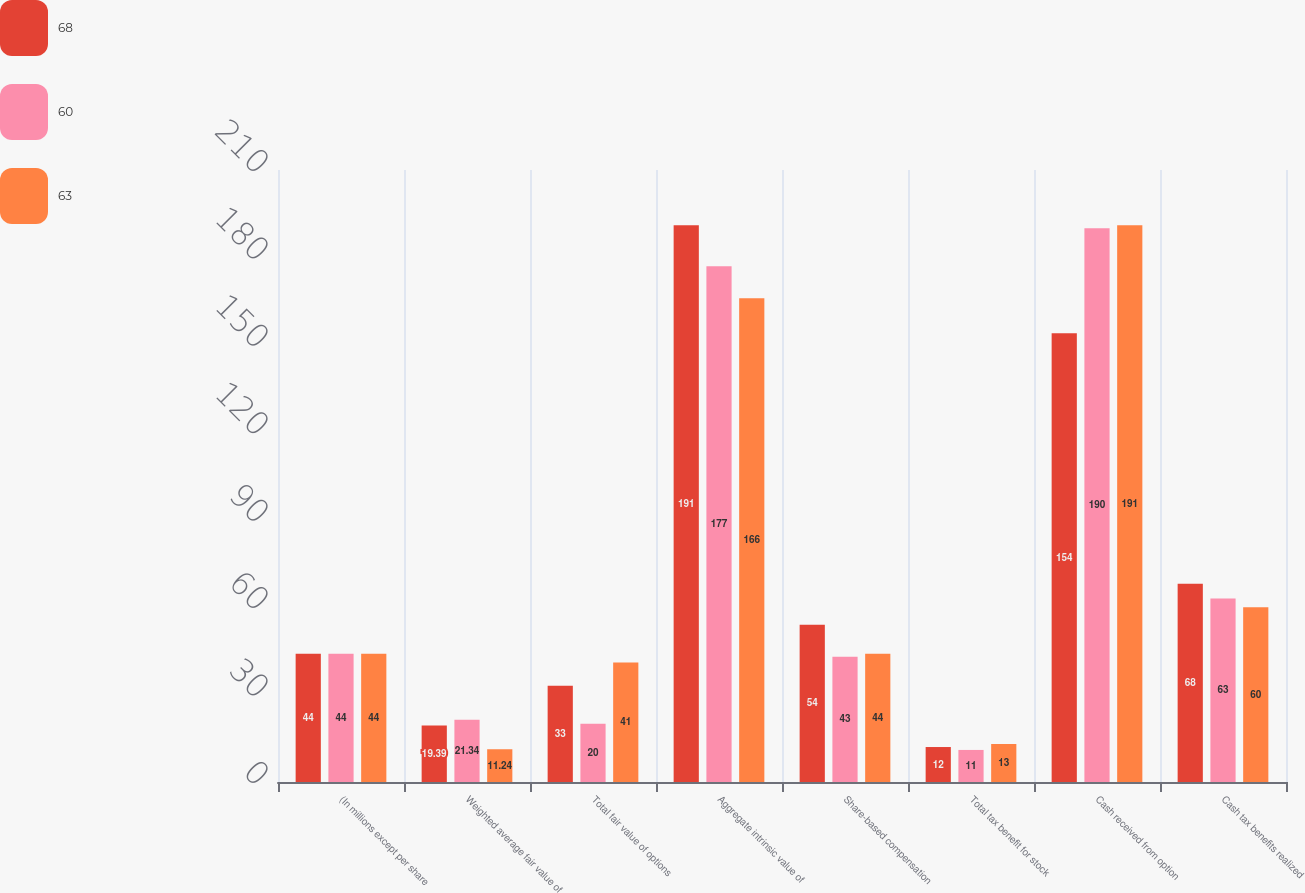Convert chart to OTSL. <chart><loc_0><loc_0><loc_500><loc_500><stacked_bar_chart><ecel><fcel>(In millions except per share<fcel>Weighted average fair value of<fcel>Total fair value of options<fcel>Aggregate intrinsic value of<fcel>Share-based compensation<fcel>Total tax benefit for stock<fcel>Cash received from option<fcel>Cash tax benefits realized<nl><fcel>68<fcel>44<fcel>19.39<fcel>33<fcel>191<fcel>54<fcel>12<fcel>154<fcel>68<nl><fcel>60<fcel>44<fcel>21.34<fcel>20<fcel>177<fcel>43<fcel>11<fcel>190<fcel>63<nl><fcel>63<fcel>44<fcel>11.24<fcel>41<fcel>166<fcel>44<fcel>13<fcel>191<fcel>60<nl></chart> 